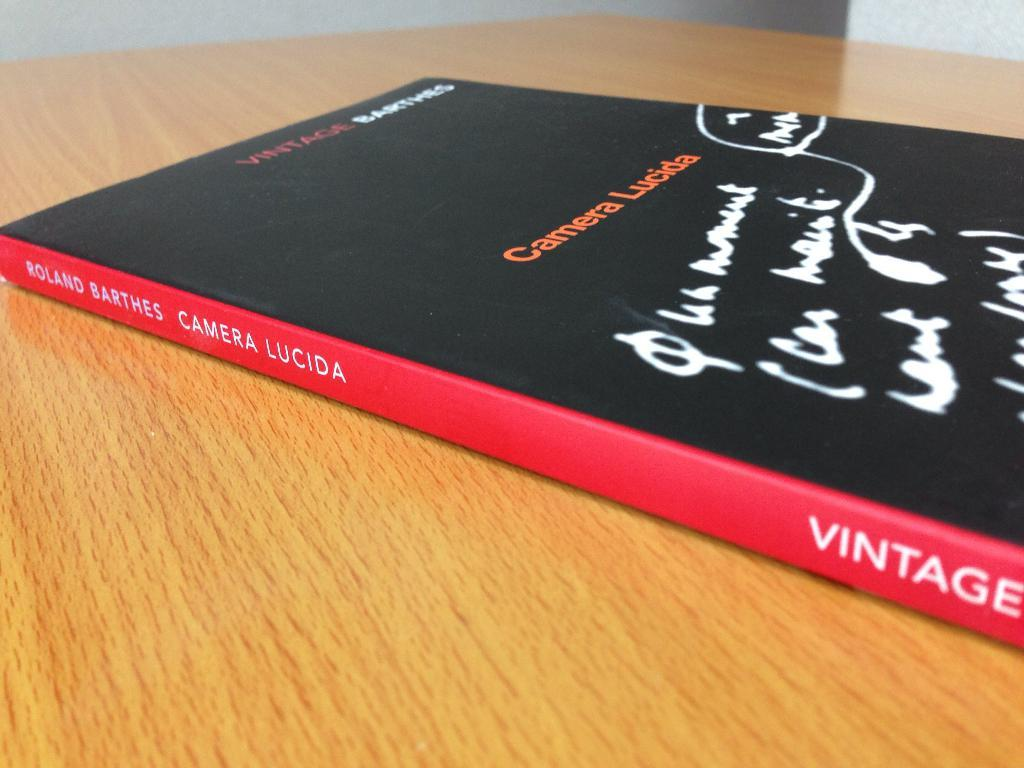<image>
Share a concise interpretation of the image provided. The book Camera Lucida by Roland Barthes on a wooden table 